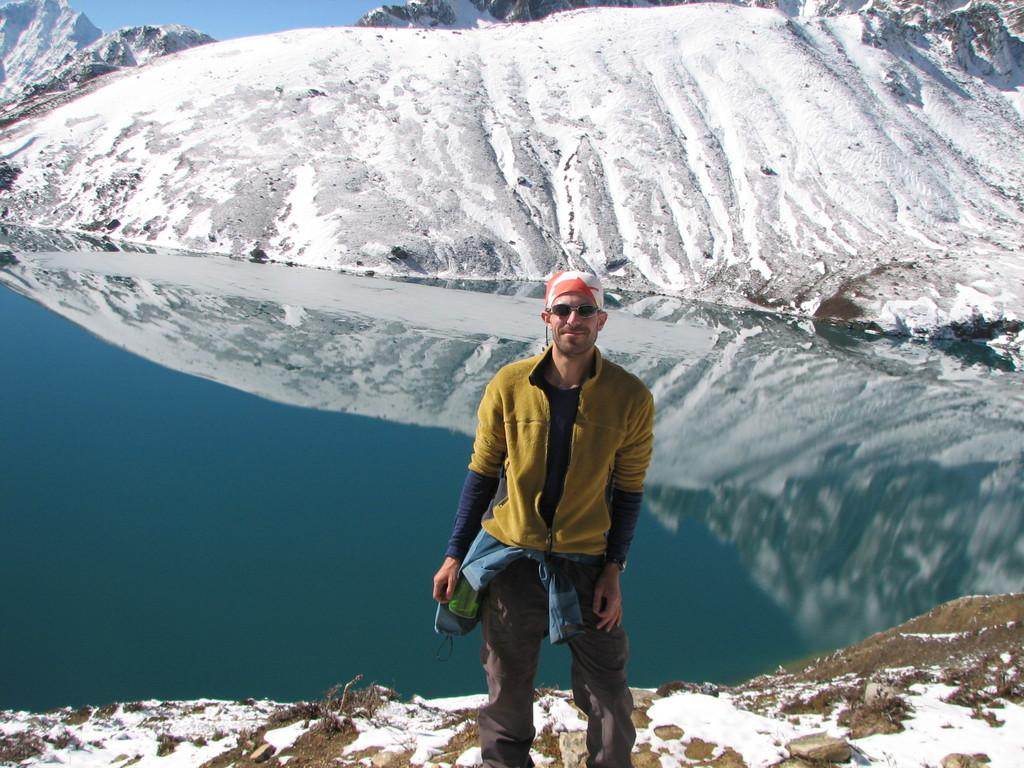What is the main subject of the image? There is a person standing in the center of the image. What is the person standing on? The person is standing on the ground. What can be seen in the background of the image? There is snow, mountains, and water visible in the background of the image. How many planes are flying over the person in the image? There are no planes visible in the image. What is the distance between the person and their partner in the image? There is no partner present in the image, so it is not possible to determine the distance between them. 